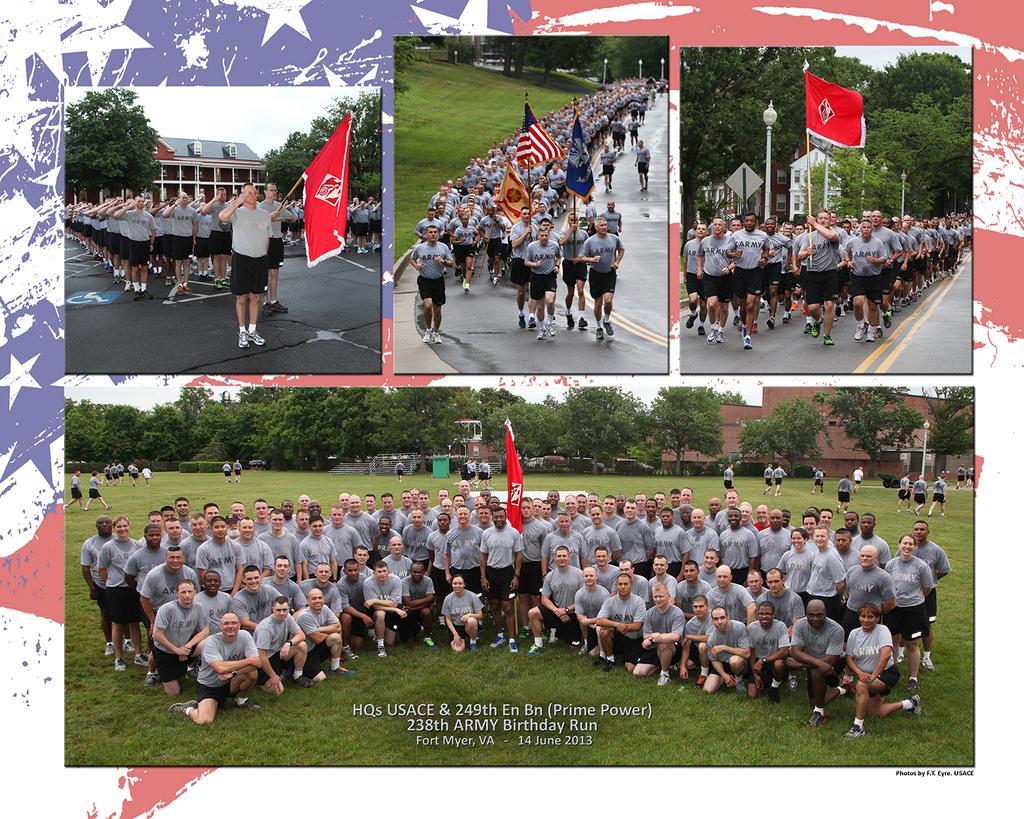Please provide a concise description of this image. This is a collage image. In this image we can see people, flags, trees, buildings and grass. 